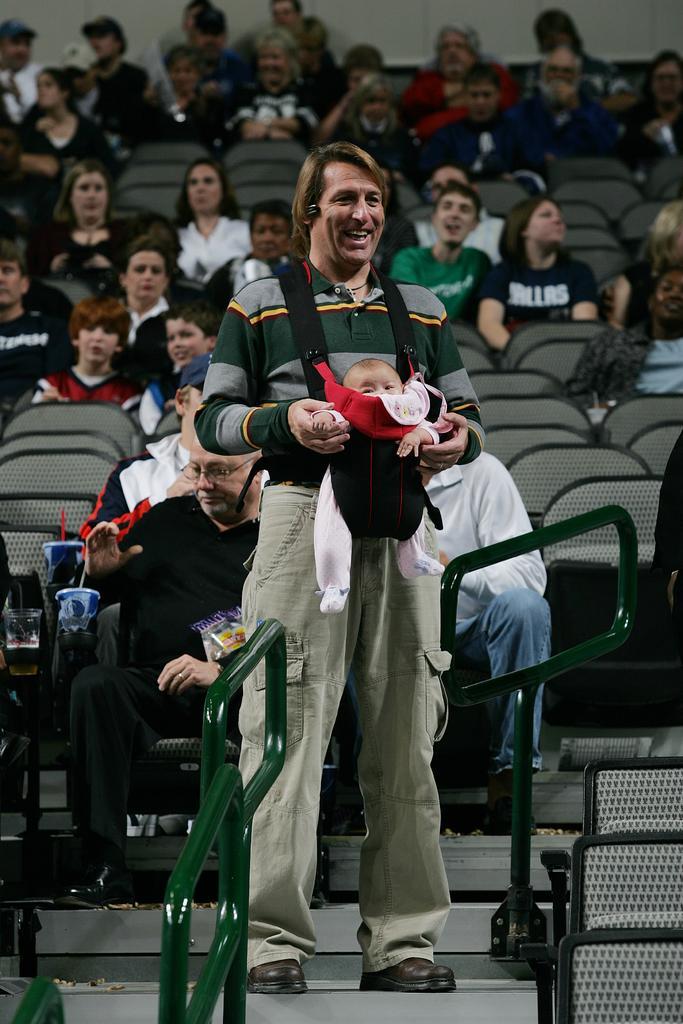In one or two sentences, can you explain what this image depicts? In this image, we can see people sitting on the chairs and there is a man standing and holding a baby and we can see railings and some objects and there are stairs. 